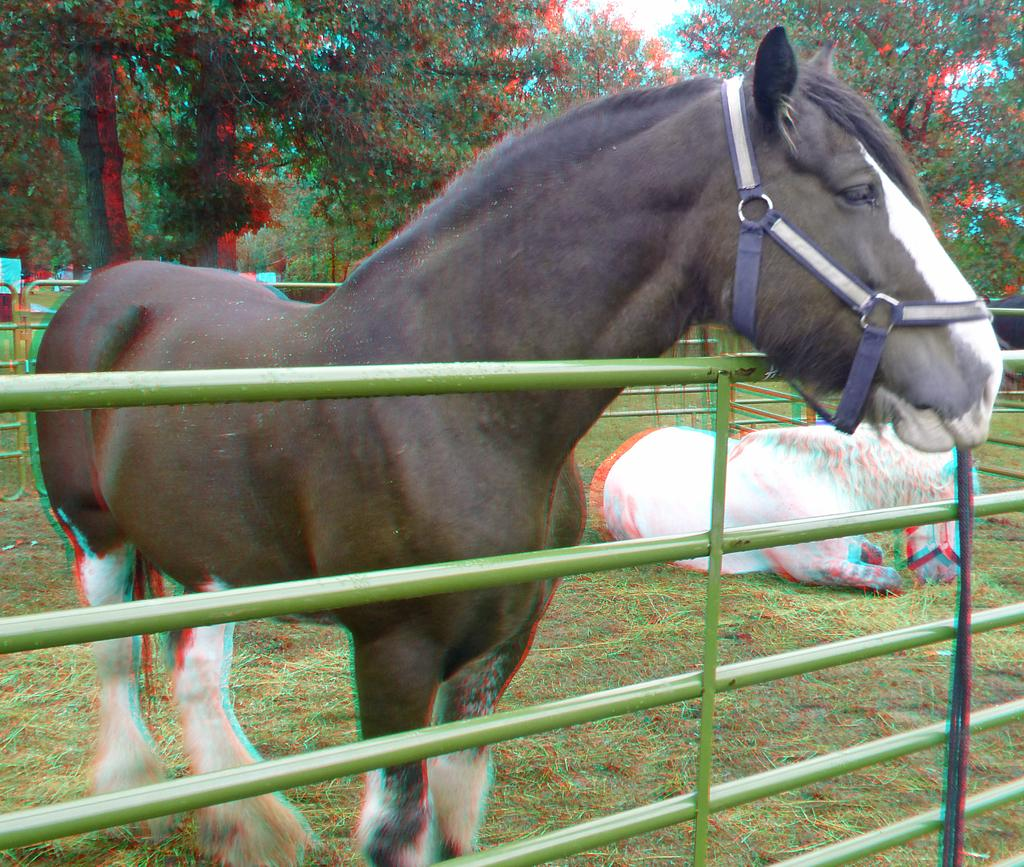What type of structure can be seen in the image? There are railings in the image, which suggests a structure like a staircase or balcony. What living creatures are present in the image? There are animals in the image. What type of vegetation can be seen in the image? There are trees and grass in the image. What else can be seen in the image besides the railings, animals, trees, and grass? There are objects in the image, but their specific nature is not mentioned in the facts. What brand of toothpaste is being advertised on the railings in the image? There is no toothpaste or advertisement present in the image. How many bees can be seen buzzing around the animals in the image? There is no mention of bees in the image, so it is impossible to determine their presence or number. 